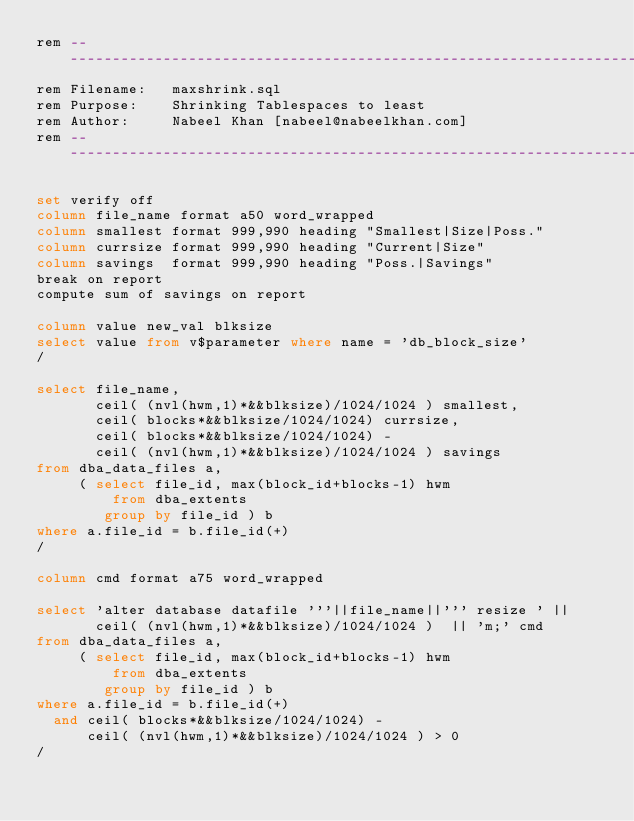Convert code to text. <code><loc_0><loc_0><loc_500><loc_500><_SQL_>rem -----------------------------------------------------------------------
rem Filename:   maxshrink.sql
rem Purpose:    Shrinking Tablespaces to least
rem Author:     Nabeel Khan [nabeel@nabeelkhan.com]
rem -----------------------------------------------------------------------

set verify off
column file_name format a50 word_wrapped
column smallest format 999,990 heading "Smallest|Size|Poss."
column currsize format 999,990 heading "Current|Size"
column savings  format 999,990 heading "Poss.|Savings"
break on report
compute sum of savings on report

column value new_val blksize
select value from v$parameter where name = 'db_block_size'
/

select file_name,
       ceil( (nvl(hwm,1)*&&blksize)/1024/1024 ) smallest,
       ceil( blocks*&&blksize/1024/1024) currsize,
       ceil( blocks*&&blksize/1024/1024) -
       ceil( (nvl(hwm,1)*&&blksize)/1024/1024 ) savings
from dba_data_files a,
     ( select file_id, max(block_id+blocks-1) hwm
         from dba_extents
        group by file_id ) b
where a.file_id = b.file_id(+)
/

column cmd format a75 word_wrapped

select 'alter database datafile '''||file_name||''' resize ' ||
       ceil( (nvl(hwm,1)*&&blksize)/1024/1024 )  || 'm;' cmd
from dba_data_files a,
     ( select file_id, max(block_id+blocks-1) hwm
         from dba_extents
        group by file_id ) b
where a.file_id = b.file_id(+)
  and ceil( blocks*&&blksize/1024/1024) -
      ceil( (nvl(hwm,1)*&&blksize)/1024/1024 ) > 0
/
</code> 